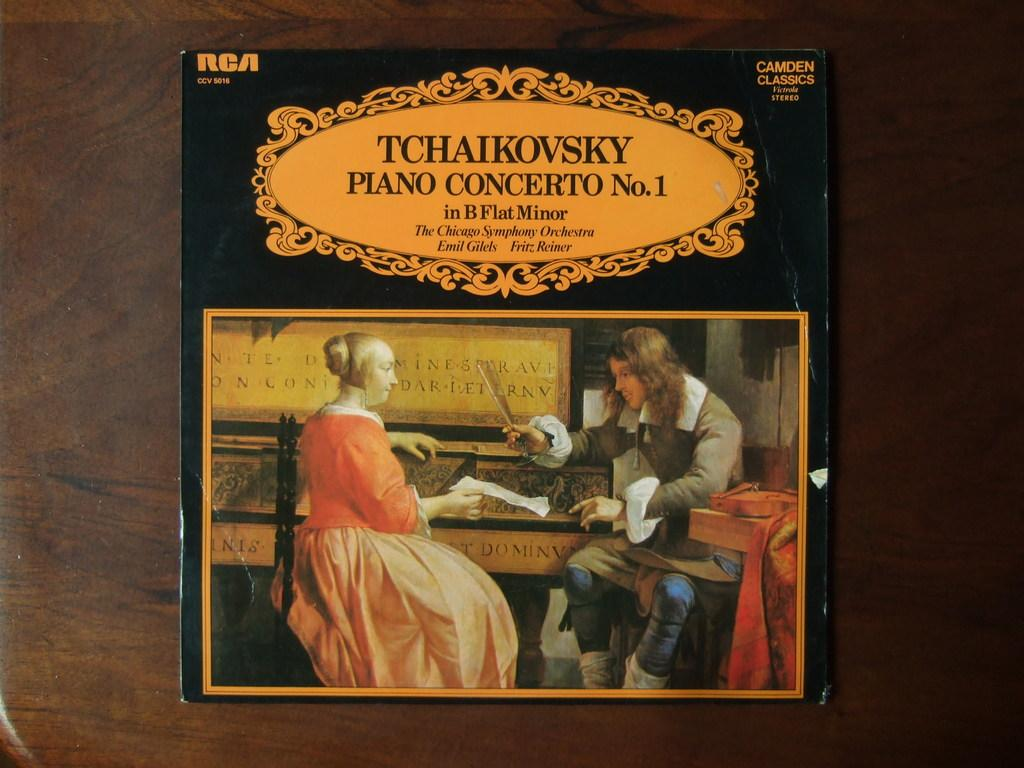<image>
Render a clear and concise summary of the photo. Tchaikovsky piano concerto record which is number one 